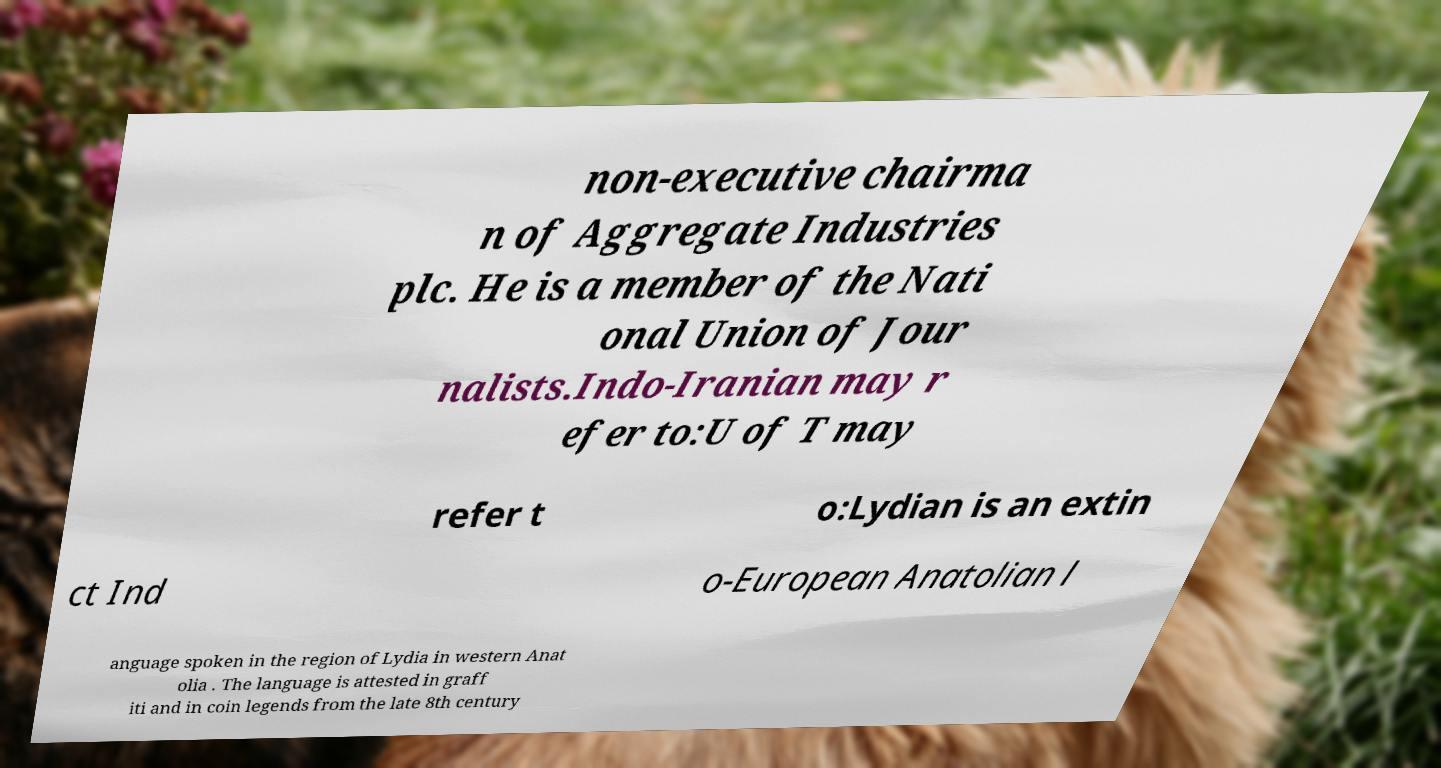There's text embedded in this image that I need extracted. Can you transcribe it verbatim? non-executive chairma n of Aggregate Industries plc. He is a member of the Nati onal Union of Jour nalists.Indo-Iranian may r efer to:U of T may refer t o:Lydian is an extin ct Ind o-European Anatolian l anguage spoken in the region of Lydia in western Anat olia . The language is attested in graff iti and in coin legends from the late 8th century 